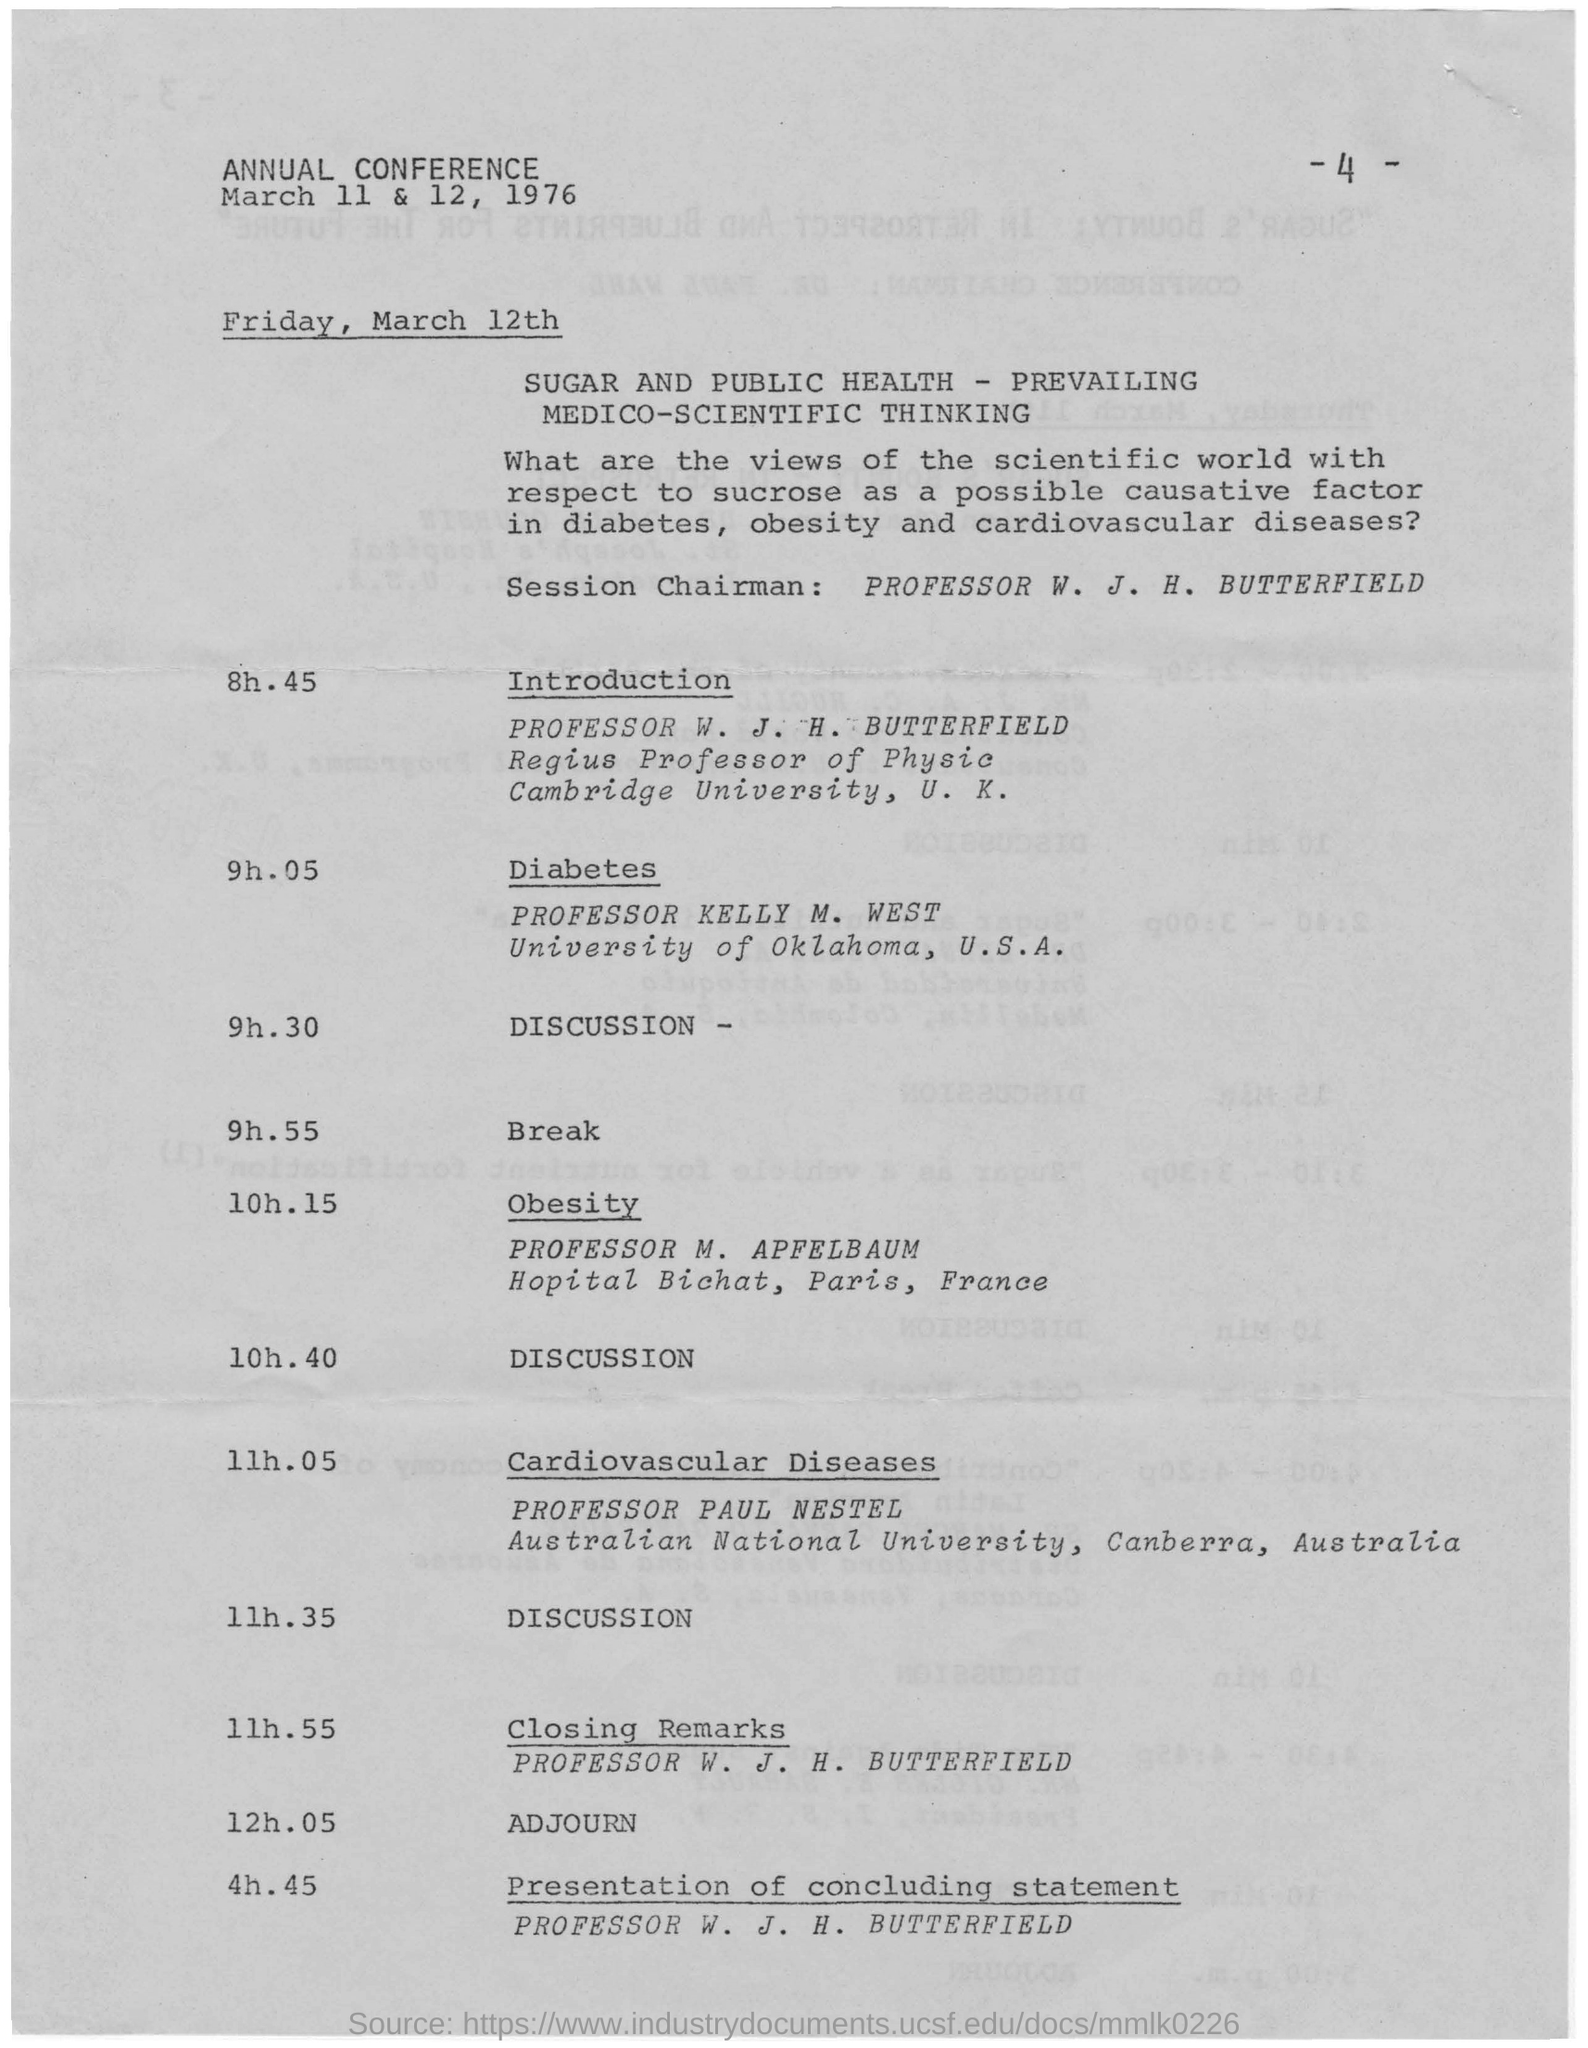Outline some significant characteristics in this image. The last name on this document is PROFESSOR W. J. H. BUTTERFIELD. The page number mentioned in this document is 4. PROFESSOR W. J. H. BUTTERFIELD is the Session Chairman. 